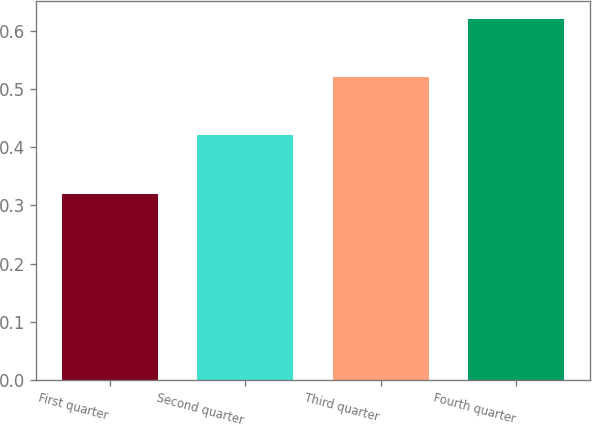<chart> <loc_0><loc_0><loc_500><loc_500><bar_chart><fcel>First quarter<fcel>Second quarter<fcel>Third quarter<fcel>Fourth quarter<nl><fcel>0.32<fcel>0.42<fcel>0.52<fcel>0.62<nl></chart> 